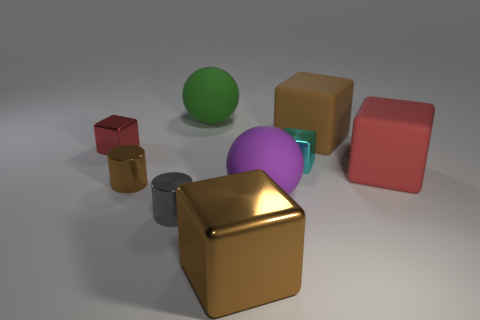Is the number of tiny gray cylinders that are behind the small gray object greater than the number of small shiny cylinders?
Make the answer very short. No. There is a big purple rubber sphere that is in front of the cyan block; how many red things are to the left of it?
Your answer should be very brief. 1. Is the material of the brown block behind the big red rubber cube the same as the large brown thing in front of the big brown rubber thing?
Offer a terse response. No. There is a cylinder that is the same color as the big metal object; what is its material?
Your answer should be very brief. Metal. What number of brown metal things have the same shape as the cyan metal object?
Keep it short and to the point. 1. Are the small red object and the red cube that is to the right of the big purple rubber thing made of the same material?
Make the answer very short. No. There is a red thing that is the same size as the green rubber thing; what material is it?
Offer a terse response. Rubber. Is there a red rubber cube that has the same size as the gray object?
Keep it short and to the point. No. What shape is the cyan metal object that is the same size as the gray object?
Your answer should be very brief. Cube. What number of other things are the same color as the large shiny block?
Your answer should be compact. 2. 